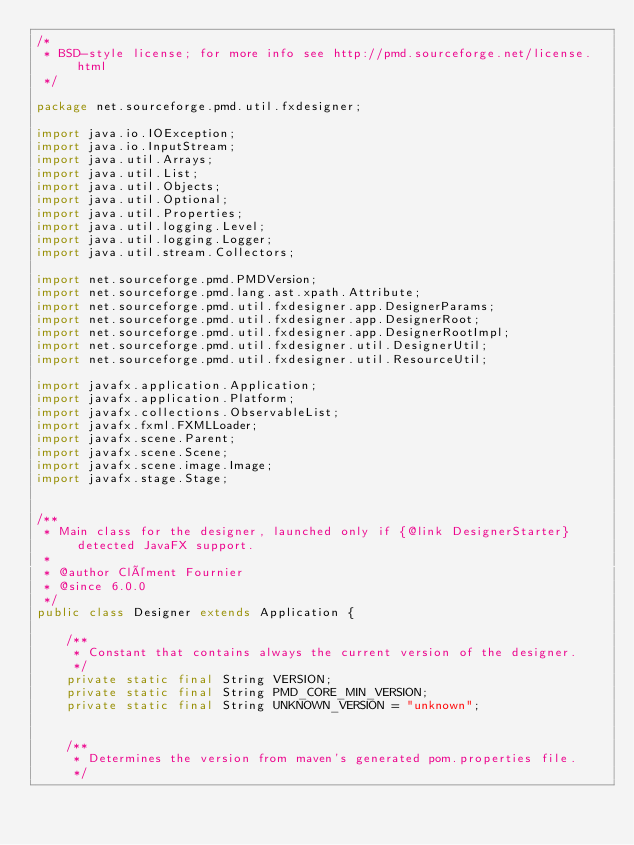<code> <loc_0><loc_0><loc_500><loc_500><_Java_>/*
 * BSD-style license; for more info see http://pmd.sourceforge.net/license.html
 */

package net.sourceforge.pmd.util.fxdesigner;

import java.io.IOException;
import java.io.InputStream;
import java.util.Arrays;
import java.util.List;
import java.util.Objects;
import java.util.Optional;
import java.util.Properties;
import java.util.logging.Level;
import java.util.logging.Logger;
import java.util.stream.Collectors;

import net.sourceforge.pmd.PMDVersion;
import net.sourceforge.pmd.lang.ast.xpath.Attribute;
import net.sourceforge.pmd.util.fxdesigner.app.DesignerParams;
import net.sourceforge.pmd.util.fxdesigner.app.DesignerRoot;
import net.sourceforge.pmd.util.fxdesigner.app.DesignerRootImpl;
import net.sourceforge.pmd.util.fxdesigner.util.DesignerUtil;
import net.sourceforge.pmd.util.fxdesigner.util.ResourceUtil;

import javafx.application.Application;
import javafx.application.Platform;
import javafx.collections.ObservableList;
import javafx.fxml.FXMLLoader;
import javafx.scene.Parent;
import javafx.scene.Scene;
import javafx.scene.image.Image;
import javafx.stage.Stage;


/**
 * Main class for the designer, launched only if {@link DesignerStarter} detected JavaFX support.
 *
 * @author Clément Fournier
 * @since 6.0.0
 */
public class Designer extends Application {

    /**
     * Constant that contains always the current version of the designer.
     */
    private static final String VERSION;
    private static final String PMD_CORE_MIN_VERSION;
    private static final String UNKNOWN_VERSION = "unknown";


    /**
     * Determines the version from maven's generated pom.properties file.
     */</code> 